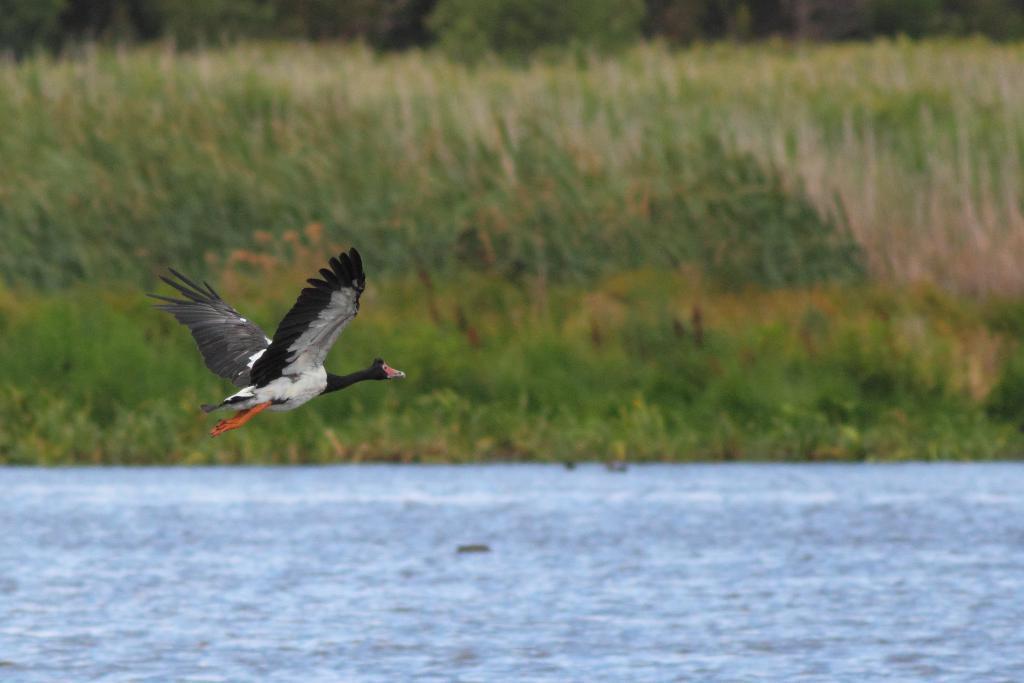Could you give a brief overview of what you see in this image? In this image we can see a bird flying in the air, here is the water, there are plants. 